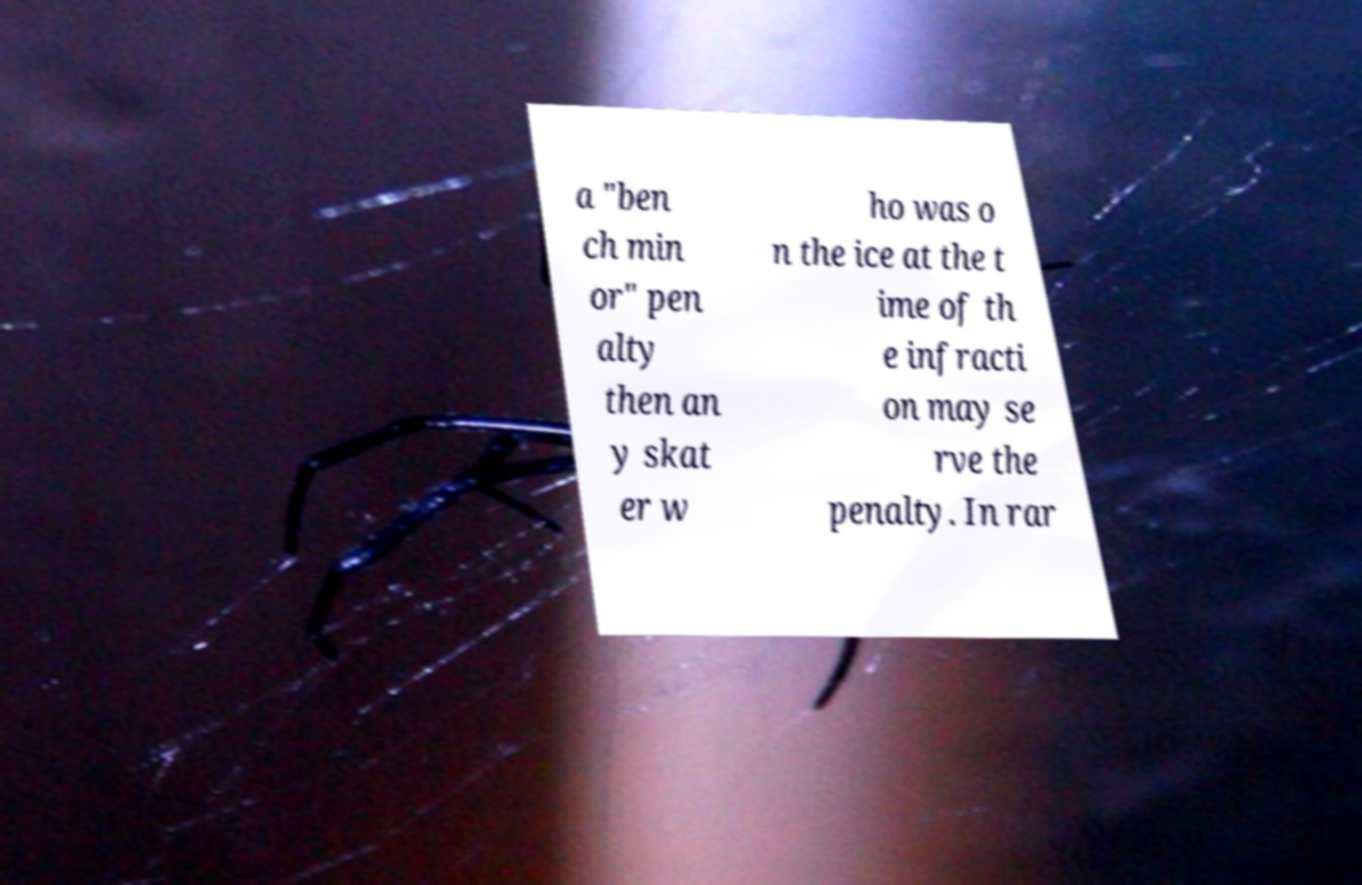I need the written content from this picture converted into text. Can you do that? a "ben ch min or" pen alty then an y skat er w ho was o n the ice at the t ime of th e infracti on may se rve the penalty. In rar 